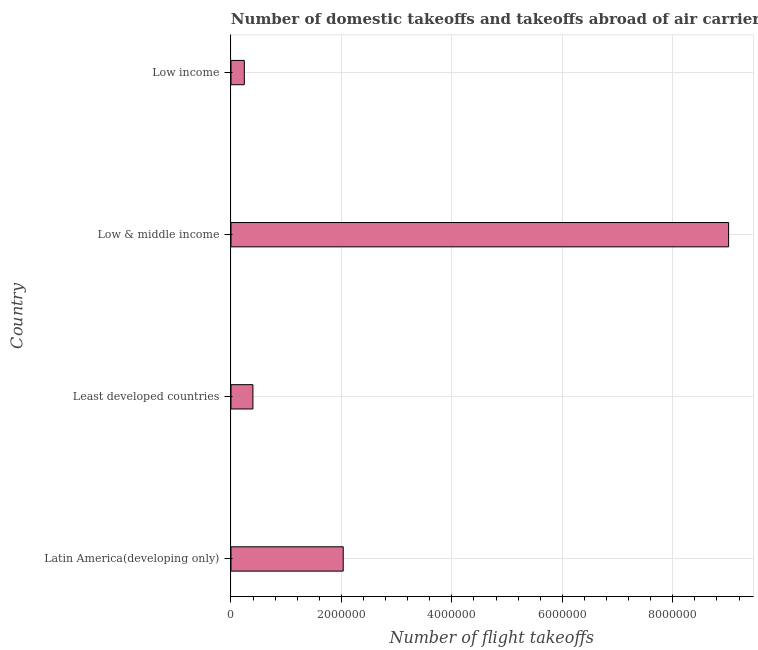Does the graph contain any zero values?
Provide a succinct answer. No. Does the graph contain grids?
Your answer should be very brief. Yes. What is the title of the graph?
Your response must be concise. Number of domestic takeoffs and takeoffs abroad of air carriers registered in countries. What is the label or title of the X-axis?
Provide a short and direct response. Number of flight takeoffs. What is the label or title of the Y-axis?
Offer a terse response. Country. What is the number of flight takeoffs in Latin America(developing only)?
Give a very brief answer. 2.03e+06. Across all countries, what is the maximum number of flight takeoffs?
Offer a terse response. 9.01e+06. Across all countries, what is the minimum number of flight takeoffs?
Provide a short and direct response. 2.42e+05. In which country was the number of flight takeoffs minimum?
Your answer should be very brief. Low income. What is the sum of the number of flight takeoffs?
Offer a terse response. 1.17e+07. What is the difference between the number of flight takeoffs in Least developed countries and Low & middle income?
Keep it short and to the point. -8.61e+06. What is the average number of flight takeoffs per country?
Give a very brief answer. 2.92e+06. What is the median number of flight takeoffs?
Provide a short and direct response. 1.21e+06. What is the ratio of the number of flight takeoffs in Latin America(developing only) to that in Least developed countries?
Give a very brief answer. 5.11. Is the difference between the number of flight takeoffs in Low & middle income and Low income greater than the difference between any two countries?
Provide a short and direct response. Yes. What is the difference between the highest and the second highest number of flight takeoffs?
Give a very brief answer. 6.98e+06. What is the difference between the highest and the lowest number of flight takeoffs?
Your answer should be very brief. 8.77e+06. How many bars are there?
Your answer should be compact. 4. Are all the bars in the graph horizontal?
Offer a very short reply. Yes. Are the values on the major ticks of X-axis written in scientific E-notation?
Provide a succinct answer. No. What is the Number of flight takeoffs in Latin America(developing only)?
Ensure brevity in your answer.  2.03e+06. What is the Number of flight takeoffs of Least developed countries?
Provide a short and direct response. 3.97e+05. What is the Number of flight takeoffs in Low & middle income?
Your answer should be very brief. 9.01e+06. What is the Number of flight takeoffs in Low income?
Provide a short and direct response. 2.42e+05. What is the difference between the Number of flight takeoffs in Latin America(developing only) and Least developed countries?
Your response must be concise. 1.64e+06. What is the difference between the Number of flight takeoffs in Latin America(developing only) and Low & middle income?
Give a very brief answer. -6.98e+06. What is the difference between the Number of flight takeoffs in Latin America(developing only) and Low income?
Keep it short and to the point. 1.79e+06. What is the difference between the Number of flight takeoffs in Least developed countries and Low & middle income?
Your response must be concise. -8.61e+06. What is the difference between the Number of flight takeoffs in Least developed countries and Low income?
Your answer should be compact. 1.56e+05. What is the difference between the Number of flight takeoffs in Low & middle income and Low income?
Your answer should be very brief. 8.77e+06. What is the ratio of the Number of flight takeoffs in Latin America(developing only) to that in Least developed countries?
Give a very brief answer. 5.11. What is the ratio of the Number of flight takeoffs in Latin America(developing only) to that in Low & middle income?
Give a very brief answer. 0.23. What is the ratio of the Number of flight takeoffs in Latin America(developing only) to that in Low income?
Offer a very short reply. 8.41. What is the ratio of the Number of flight takeoffs in Least developed countries to that in Low & middle income?
Provide a short and direct response. 0.04. What is the ratio of the Number of flight takeoffs in Least developed countries to that in Low income?
Your answer should be compact. 1.65. What is the ratio of the Number of flight takeoffs in Low & middle income to that in Low income?
Keep it short and to the point. 37.29. 